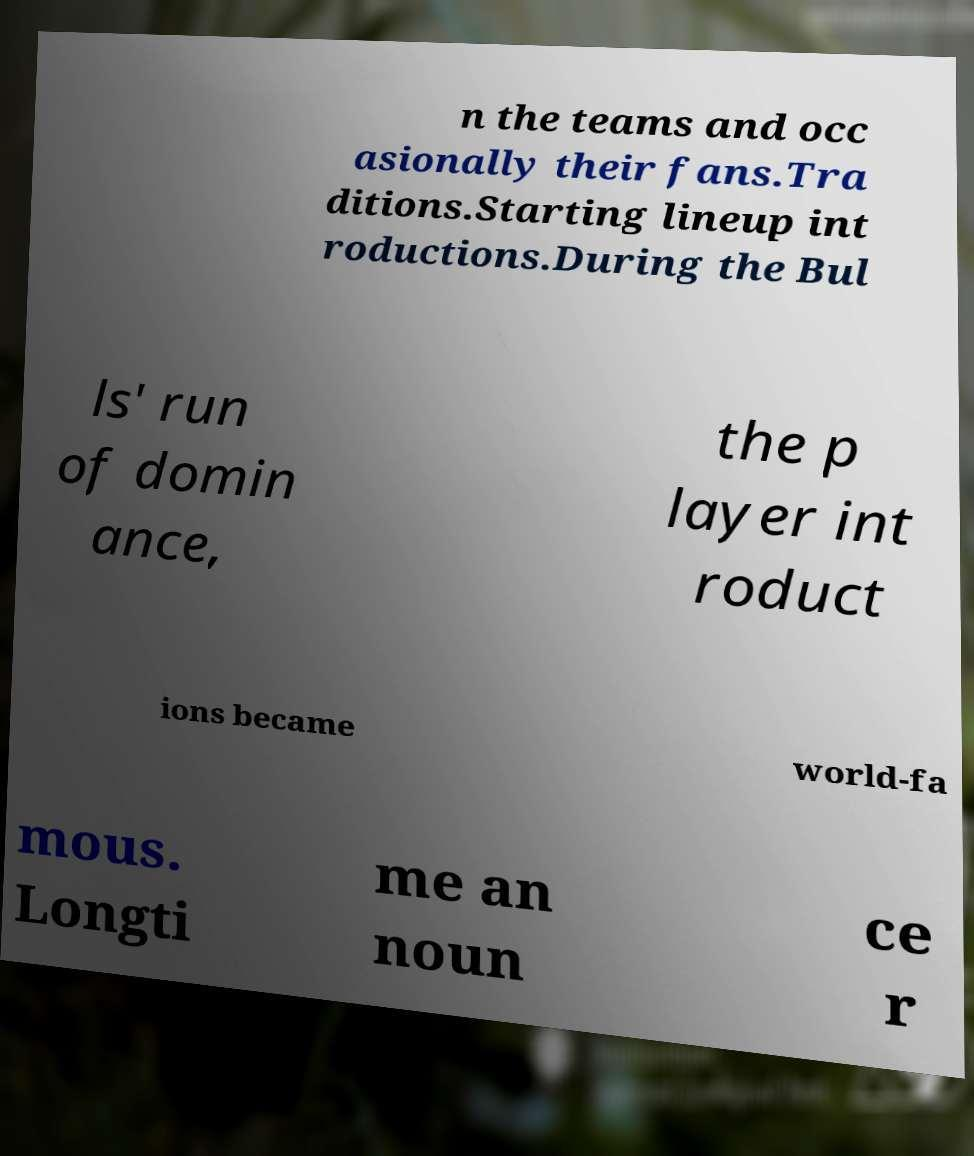Please identify and transcribe the text found in this image. n the teams and occ asionally their fans.Tra ditions.Starting lineup int roductions.During the Bul ls' run of domin ance, the p layer int roduct ions became world-fa mous. Longti me an noun ce r 